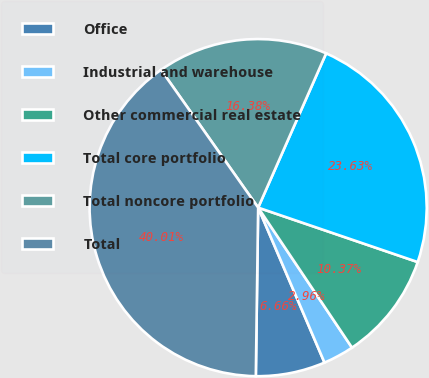<chart> <loc_0><loc_0><loc_500><loc_500><pie_chart><fcel>Office<fcel>Industrial and warehouse<fcel>Other commercial real estate<fcel>Total core portfolio<fcel>Total noncore portfolio<fcel>Total<nl><fcel>6.66%<fcel>2.96%<fcel>10.37%<fcel>23.63%<fcel>16.38%<fcel>40.01%<nl></chart> 